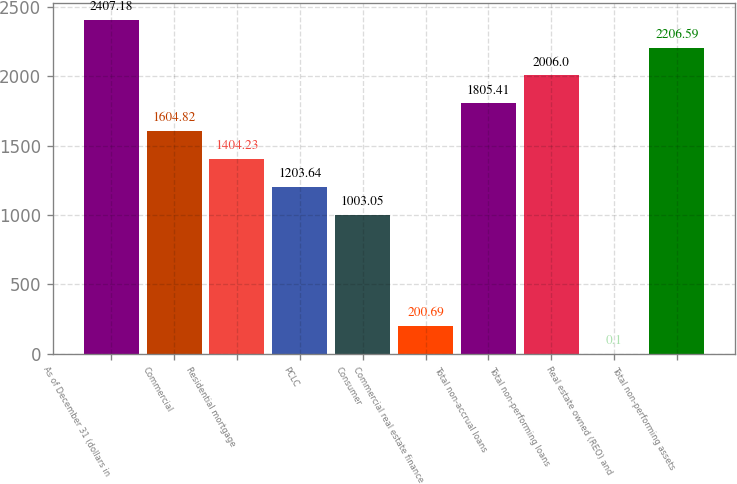Convert chart to OTSL. <chart><loc_0><loc_0><loc_500><loc_500><bar_chart><fcel>As of December 31 (dollars in<fcel>Commercial<fcel>Residential mortgage<fcel>PCLC<fcel>Consumer<fcel>Commercial real estate finance<fcel>Total non-accrual loans<fcel>Total non-performing loans<fcel>Real estate owned (REO) and<fcel>Total non-performing assets<nl><fcel>2407.18<fcel>1604.82<fcel>1404.23<fcel>1203.64<fcel>1003.05<fcel>200.69<fcel>1805.41<fcel>2006<fcel>0.1<fcel>2206.59<nl></chart> 